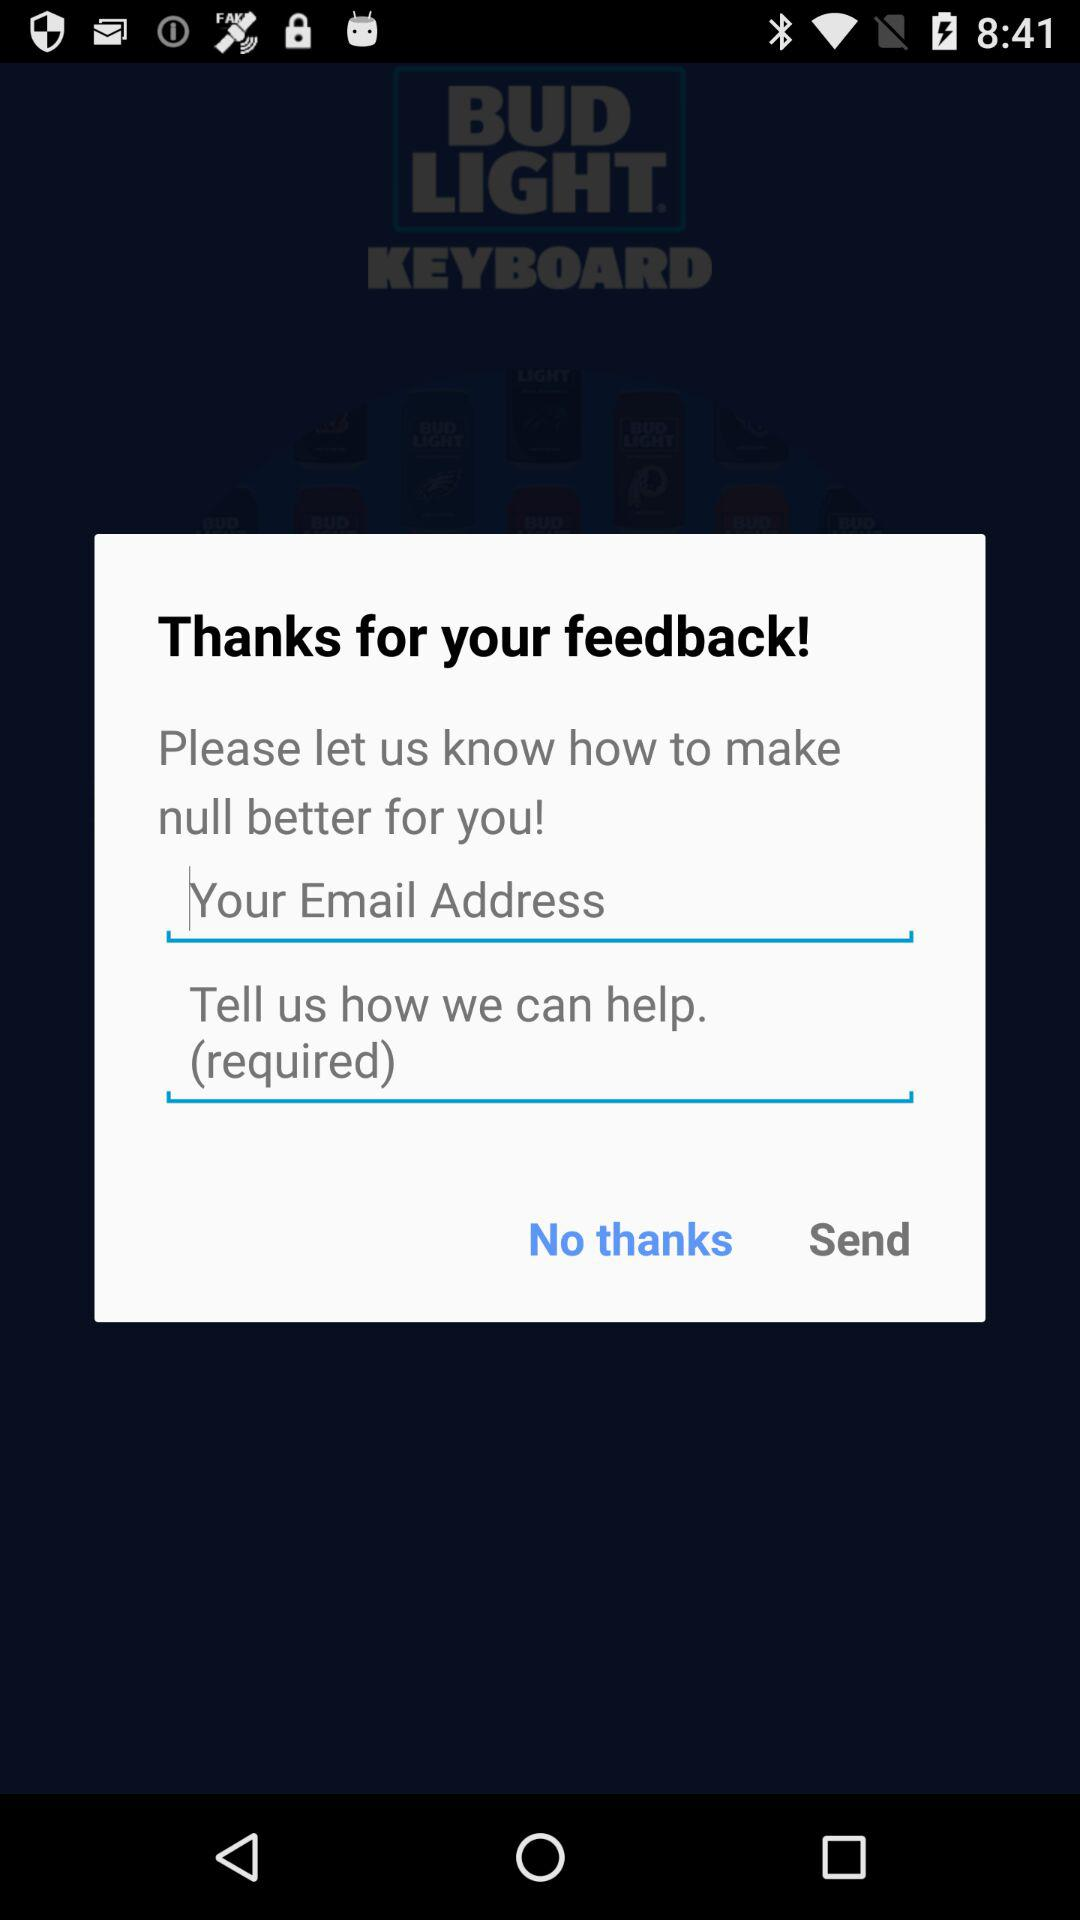How many required fields are there on this screen?
Answer the question using a single word or phrase. 2 